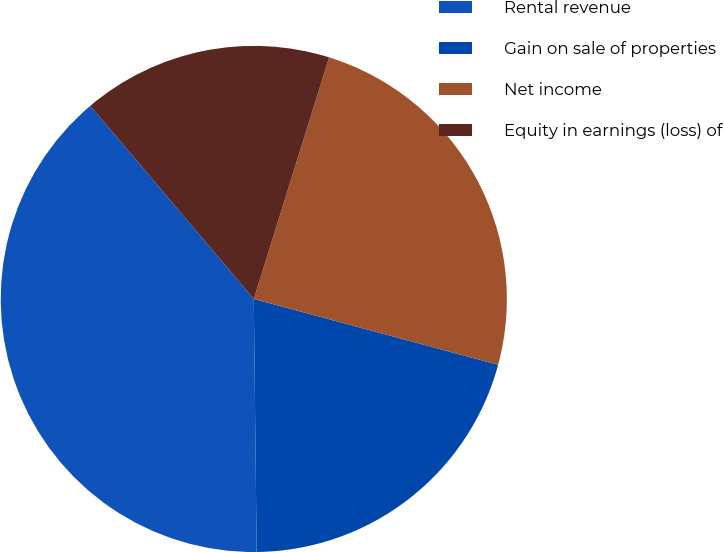Convert chart. <chart><loc_0><loc_0><loc_500><loc_500><pie_chart><fcel>Rental revenue<fcel>Gain on sale of properties<fcel>Net income<fcel>Equity in earnings (loss) of<nl><fcel>39.0%<fcel>20.63%<fcel>24.38%<fcel>15.99%<nl></chart> 